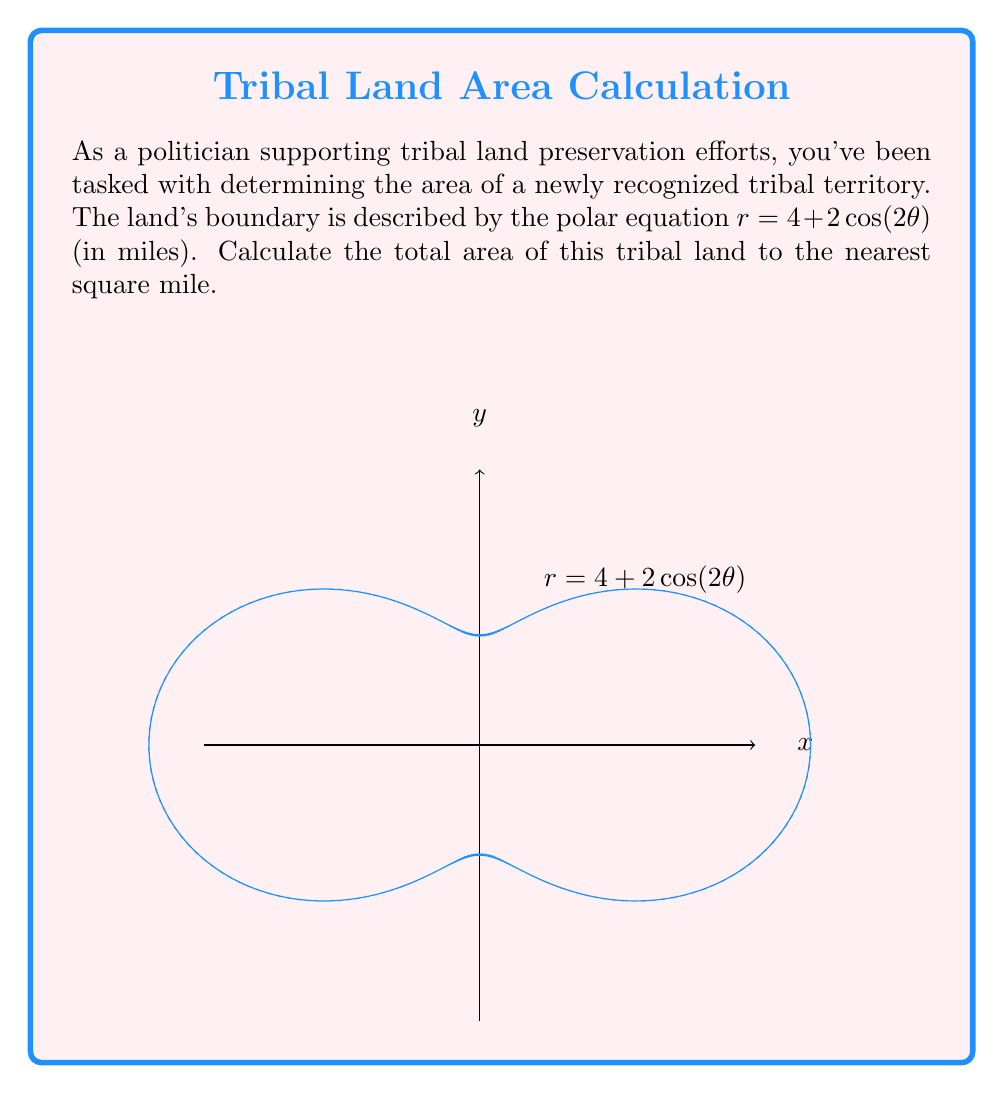Can you answer this question? To find the area enclosed by a polar curve, we use the formula:

$$ A = \frac{1}{2} \int_0^{2\pi} r^2(\theta) \, d\theta $$

1) First, we square the given function:
   $r^2 = (4 + 2\cos(2\theta))^2 = 16 + 16\cos(2\theta) + 4\cos^2(2\theta)$

2) Expand using the identity $\cos^2(x) = \frac{1}{2}(1 + \cos(2x))$:
   $r^2 = 16 + 16\cos(2\theta) + 4 \cdot \frac{1}{2}(1 + \cos(4\theta))$
   $r^2 = 18 + 16\cos(2\theta) + 2\cos(4\theta)$

3) Now we set up the integral:
   $$ A = \frac{1}{2} \int_0^{2\pi} (18 + 16\cos(2\theta) + 2\cos(4\theta)) \, d\theta $$

4) Integrate term by term:
   $$ A = \frac{1}{2} \left[ 18\theta + 8\sin(2\theta) + \frac{1}{2}\sin(4\theta) \right]_0^{2\pi} $$

5) Evaluate the integral:
   $$ A = \frac{1}{2} \left[ 18(2\pi) + 8(0) + \frac{1}{2}(0) \right] = 9\pi $$

6) Convert to square miles (rounded to the nearest whole number):
   $9\pi \approx 28.27 \approx 28$ square miles
Answer: 28 square miles 